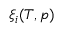<formula> <loc_0><loc_0><loc_500><loc_500>\xi _ { i } ( T , p )</formula> 